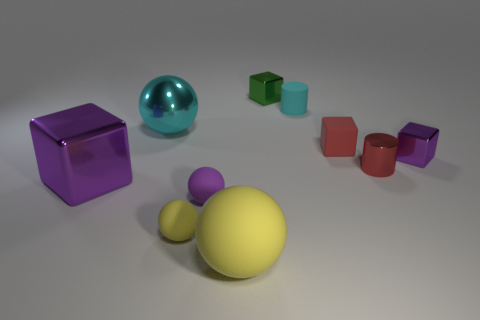There is a ball that is the same color as the tiny matte cylinder; what size is it?
Make the answer very short. Large. What number of objects have the same color as the big shiny ball?
Give a very brief answer. 1. Is the large matte object the same color as the small rubber cylinder?
Ensure brevity in your answer.  No. There is a purple ball that is to the left of the large yellow matte object; does it have the same size as the red thing that is in front of the tiny red block?
Provide a short and direct response. Yes. Is there anything else that has the same material as the big cyan thing?
Make the answer very short. Yes. How many things are cylinders behind the small matte cube or purple blocks that are to the right of the red metal object?
Provide a succinct answer. 2. Are the large cyan sphere and the purple cube to the left of the tiny purple matte sphere made of the same material?
Keep it short and to the point. Yes. What is the shape of the metallic thing that is on the left side of the tiny metal cylinder and in front of the red rubber block?
Your response must be concise. Cube. How many other objects are there of the same color as the matte cube?
Keep it short and to the point. 1. What shape is the small yellow thing?
Make the answer very short. Sphere. 